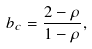Convert formula to latex. <formula><loc_0><loc_0><loc_500><loc_500>b _ { c } = \frac { 2 - \rho } { 1 - \rho } ,</formula> 